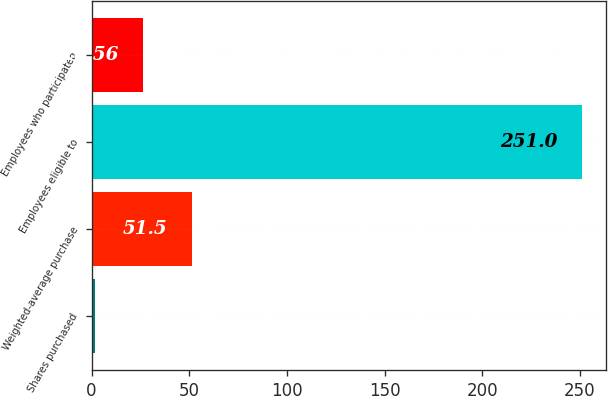<chart> <loc_0><loc_0><loc_500><loc_500><bar_chart><fcel>Shares purchased<fcel>Weighted-average purchase<fcel>Employees eligible to<fcel>Employees who participated<nl><fcel>1.62<fcel>51.5<fcel>251<fcel>26.56<nl></chart> 